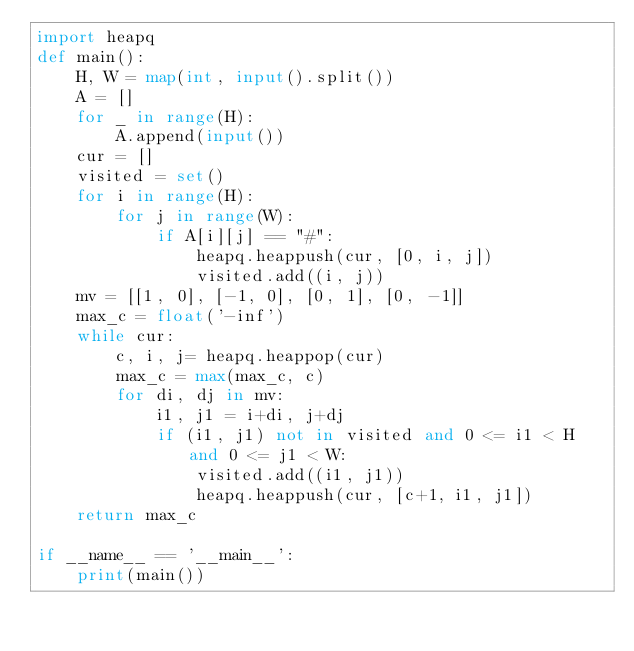Convert code to text. <code><loc_0><loc_0><loc_500><loc_500><_Python_>import heapq
def main():
    H, W = map(int, input().split())
    A = []
    for _ in range(H):
        A.append(input())
    cur = []
    visited = set()
    for i in range(H):
        for j in range(W):
            if A[i][j] == "#":
                heapq.heappush(cur, [0, i, j])
                visited.add((i, j))
    mv = [[1, 0], [-1, 0], [0, 1], [0, -1]]
    max_c = float('-inf')
    while cur:
        c, i, j= heapq.heappop(cur)
        max_c = max(max_c, c)
        for di, dj in mv:
            i1, j1 = i+di, j+dj
            if (i1, j1) not in visited and 0 <= i1 < H and 0 <= j1 < W:
                visited.add((i1, j1))
                heapq.heappush(cur, [c+1, i1, j1])
    return max_c

if __name__ == '__main__':
    print(main())</code> 